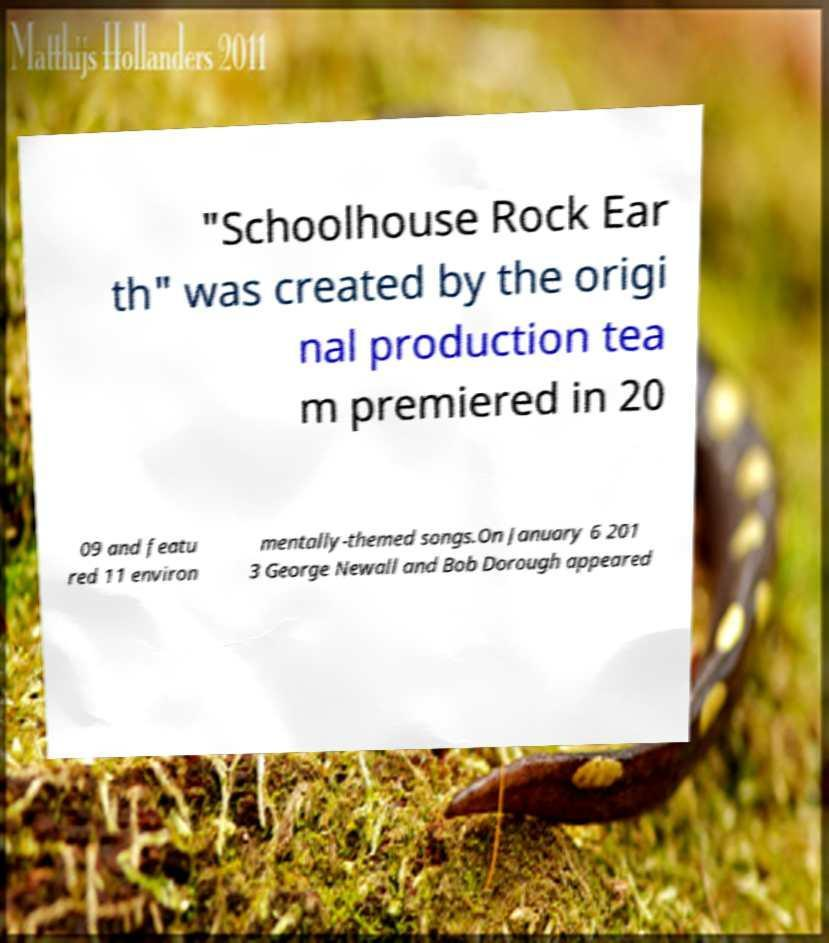I need the written content from this picture converted into text. Can you do that? "Schoolhouse Rock Ear th" was created by the origi nal production tea m premiered in 20 09 and featu red 11 environ mentally-themed songs.On January 6 201 3 George Newall and Bob Dorough appeared 